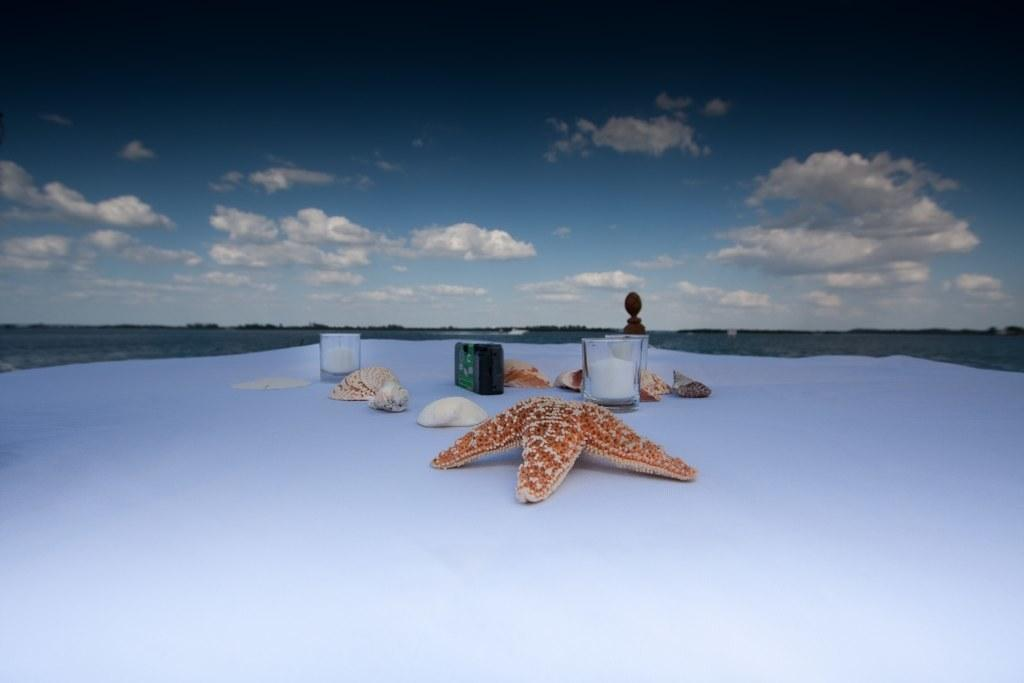What is the main subject in the foreground of the image? There is a starfish in the foreground of the image. What other objects can be seen in the foreground of the image? There are glasses, a shell, and a stone visible in the foreground of the image. What is the white surface that these objects are placed on? The other objects are visible on a white surface in the foreground of the image. What is visible at the top of the image? The sky is visible at the top of the image. How many lizards can be seen crawling on the brain in the image? There are no lizards or brains present in the image; it features a starfish, glasses, a shell, and a stone on a white surface with the sky visible at the top. 